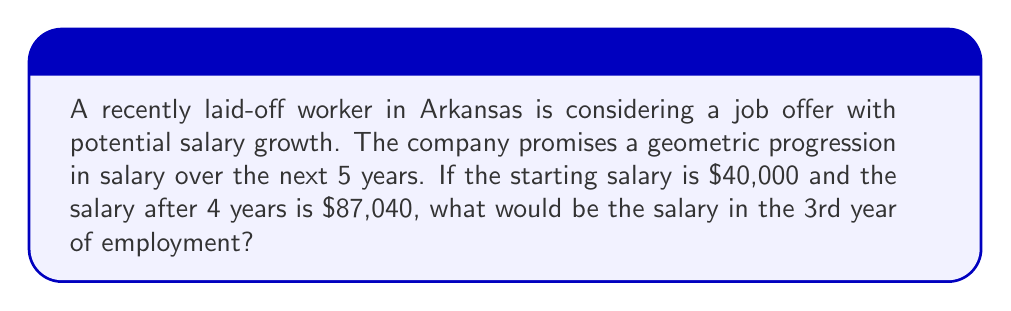Provide a solution to this math problem. Let's approach this step-by-step:

1) In a geometric sequence, each term is a constant multiple of the previous term. Let's call this constant $r$.

2) We know the first term $a_1 = 40000$ and the 5th term $a_5 = 87040$.

3) In a geometric sequence, $a_n = a_1 \cdot r^{n-1}$, where $n$ is the term number.

4) Using this formula for the 5th term:
   $$87040 = 40000 \cdot r^4$$

5) Dividing both sides by 40000:
   $$2.176 = r^4$$

6) Taking the 4th root of both sides:
   $$r = \sqrt[4]{2.176} \approx 1.2$$

7) So, each year the salary increases by approximately 20%.

8) Now, to find the 3rd year salary, we use the formula again:
   $$a_3 = 40000 \cdot 1.2^2 = 40000 \cdot 1.44 = 57600$$

Therefore, the salary in the 3rd year would be $57,600.
Answer: $57,600 